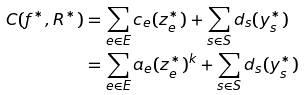<formula> <loc_0><loc_0><loc_500><loc_500>C ( f ^ { * } , R ^ { * } ) & = \sum _ { e \in E } c _ { e } ( z _ { e } ^ { * } ) + \sum _ { s \in S } d _ { s } ( y _ { s } ^ { * } ) \\ & = \sum _ { e \in E } a _ { e } ( z _ { e } ^ { * } ) ^ { k } + \sum _ { s \in S } d _ { s } ( y _ { s } ^ { * } )</formula> 